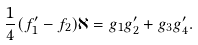<formula> <loc_0><loc_0><loc_500><loc_500>\frac { 1 } { 4 } ( f _ { 1 } ^ { \prime } - f _ { 2 } ) \aleph = g _ { 1 } g _ { 2 } ^ { \prime } + g _ { 3 } g _ { 4 } ^ { \prime } .</formula> 